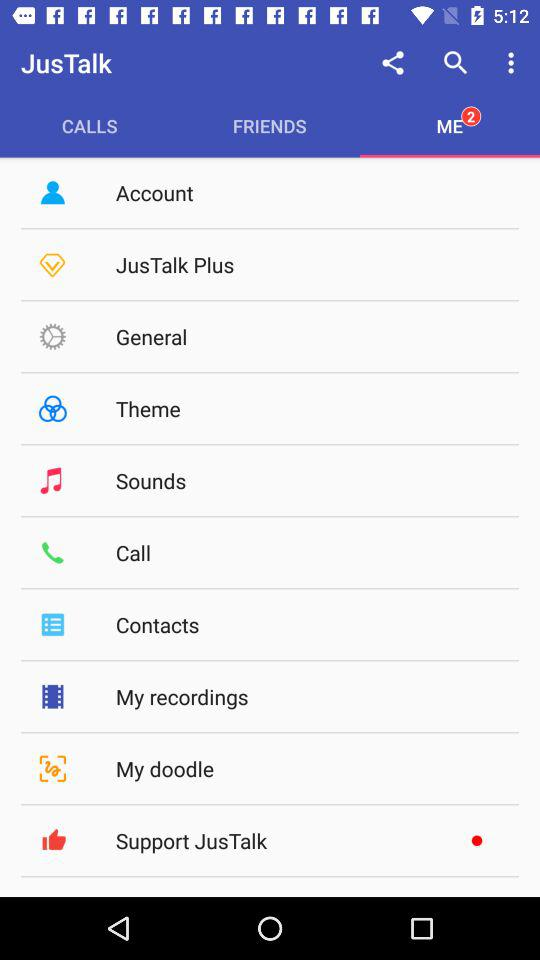What is the count of notifications? The count of notifications is 2. 